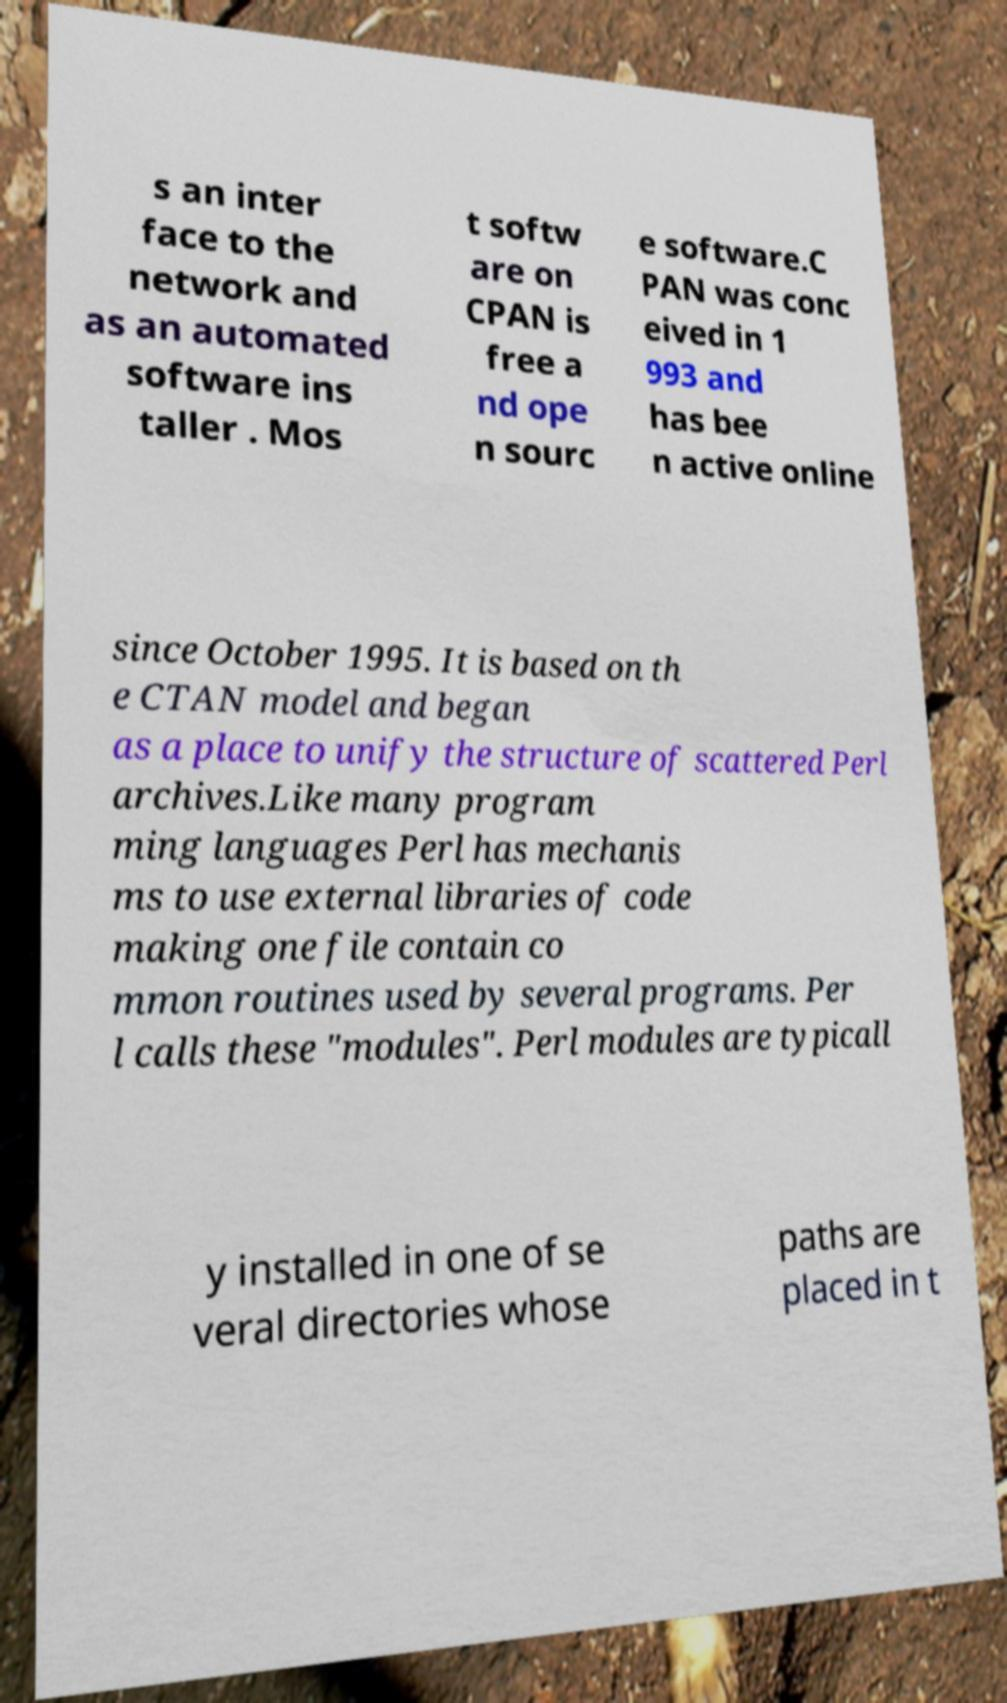Can you read and provide the text displayed in the image?This photo seems to have some interesting text. Can you extract and type it out for me? s an inter face to the network and as an automated software ins taller . Mos t softw are on CPAN is free a nd ope n sourc e software.C PAN was conc eived in 1 993 and has bee n active online since October 1995. It is based on th e CTAN model and began as a place to unify the structure of scattered Perl archives.Like many program ming languages Perl has mechanis ms to use external libraries of code making one file contain co mmon routines used by several programs. Per l calls these "modules". Perl modules are typicall y installed in one of se veral directories whose paths are placed in t 